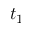<formula> <loc_0><loc_0><loc_500><loc_500>t _ { 1 }</formula> 